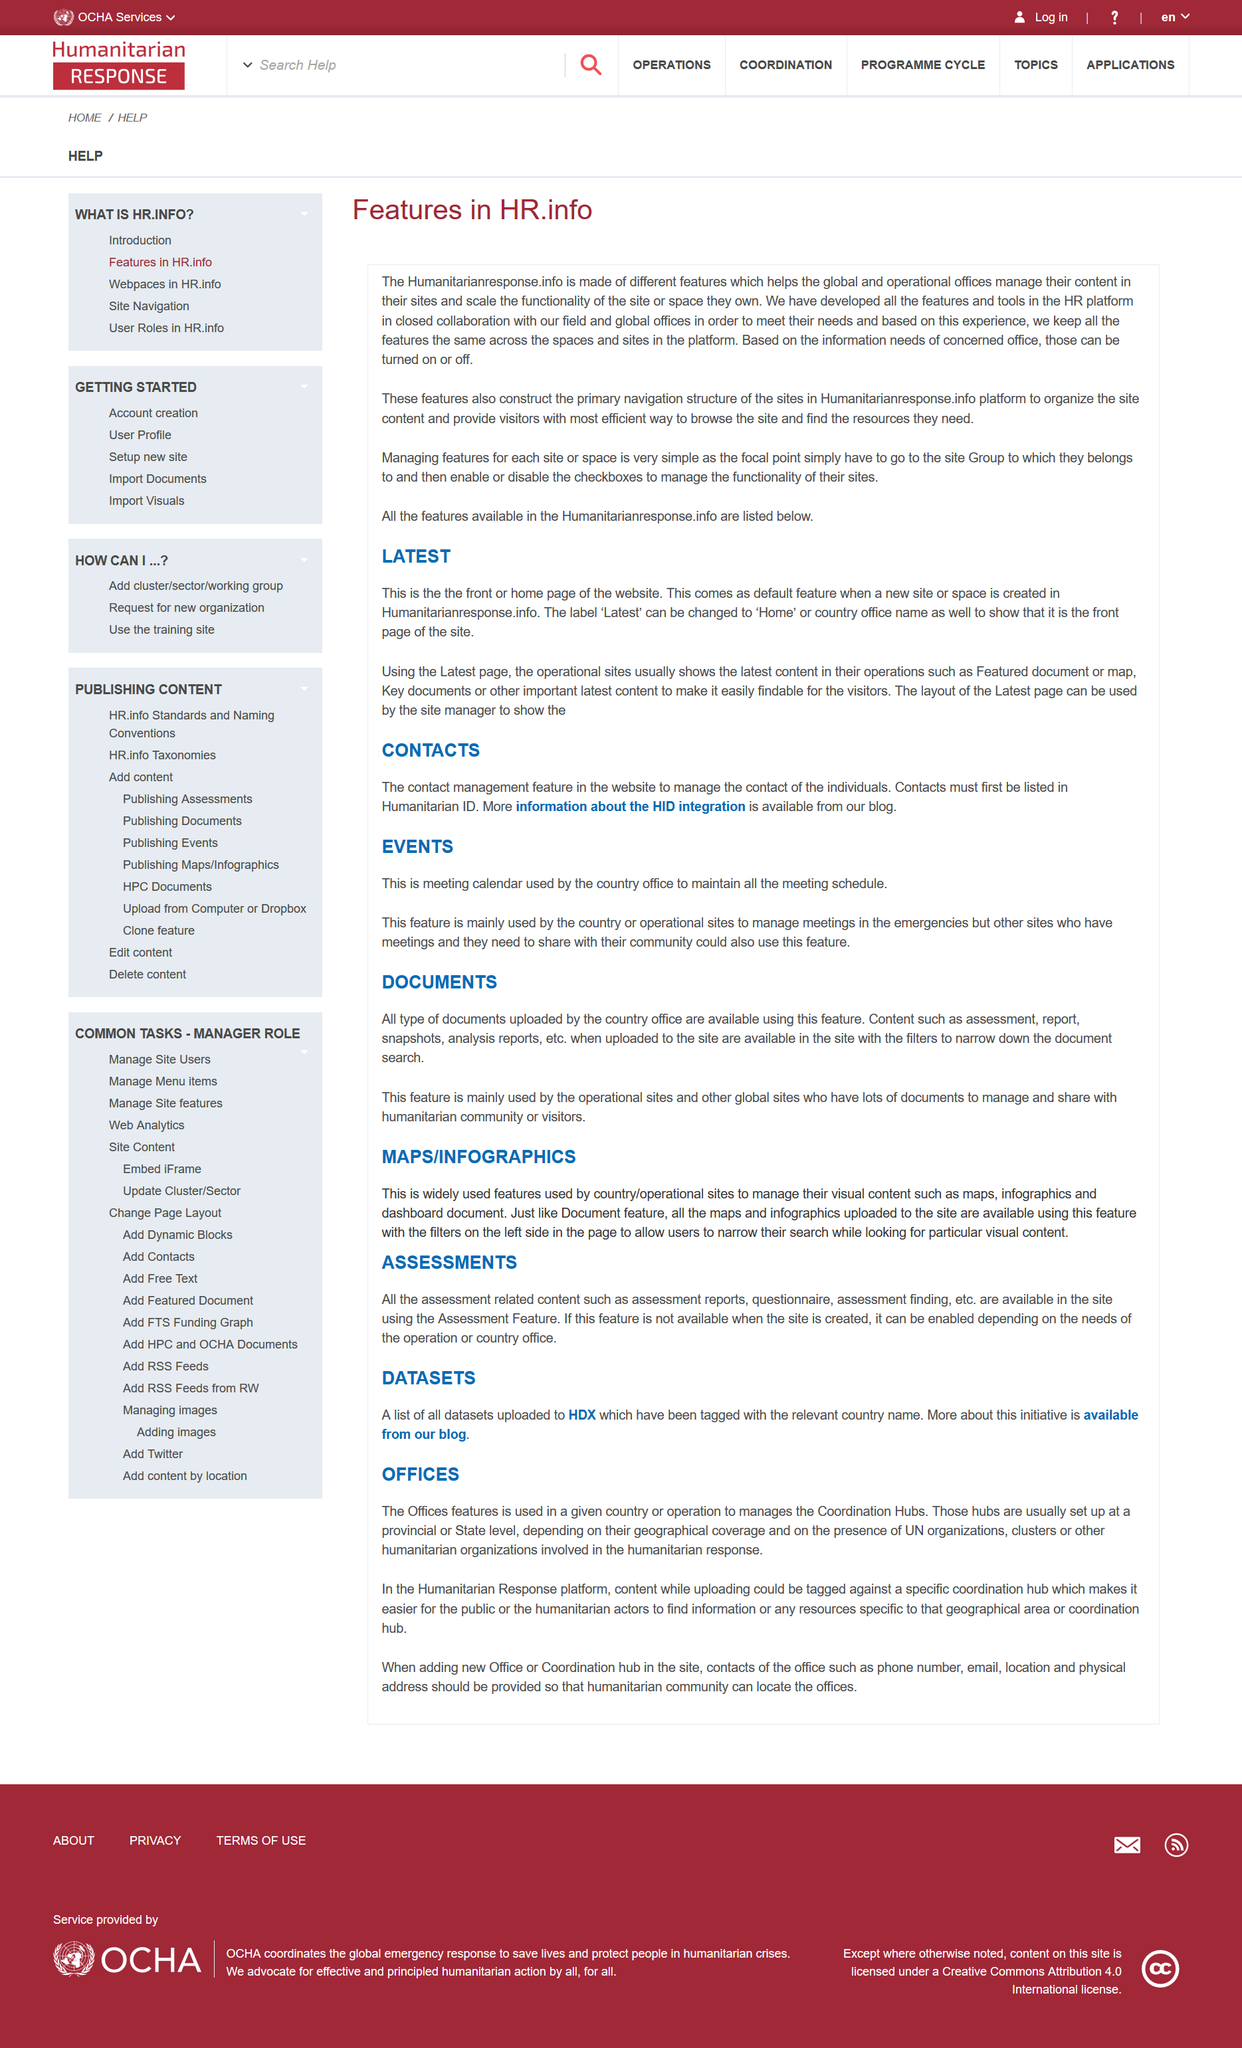Specify some key components in this picture. The most recent content is displayed on the latest page. Humanitarianresponse.info is commonly referred to as HR.info. Checkboxes are employed in HR.info. The Assessment Feature is used to manage assessment reports, questionnaire, and assessment findings. The Offices feature is used in a given country or operation to manage the Coordination Hubs. 